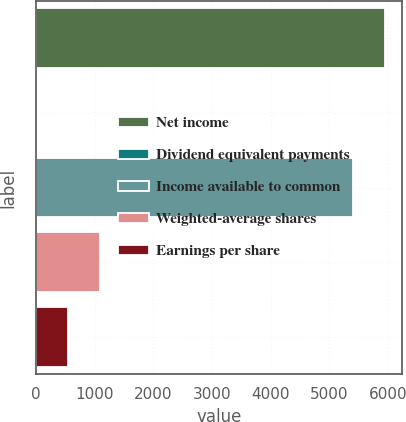Convert chart. <chart><loc_0><loc_0><loc_500><loc_500><bar_chart><fcel>Net income<fcel>Dividend equivalent payments<fcel>Income available to common<fcel>Weighted-average shares<fcel>Earnings per share<nl><fcel>5940<fcel>4<fcel>5400<fcel>1084<fcel>544<nl></chart> 